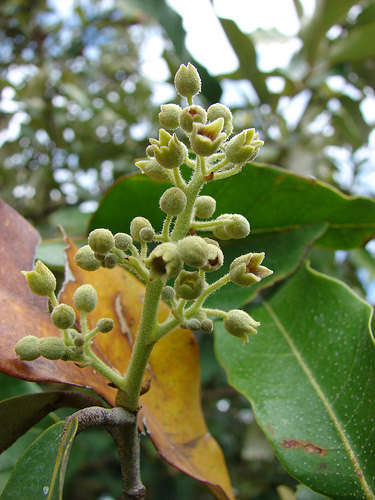<image>
Can you confirm if the buds is on the leaf? No. The buds is not positioned on the leaf. They may be near each other, but the buds is not supported by or resting on top of the leaf. 